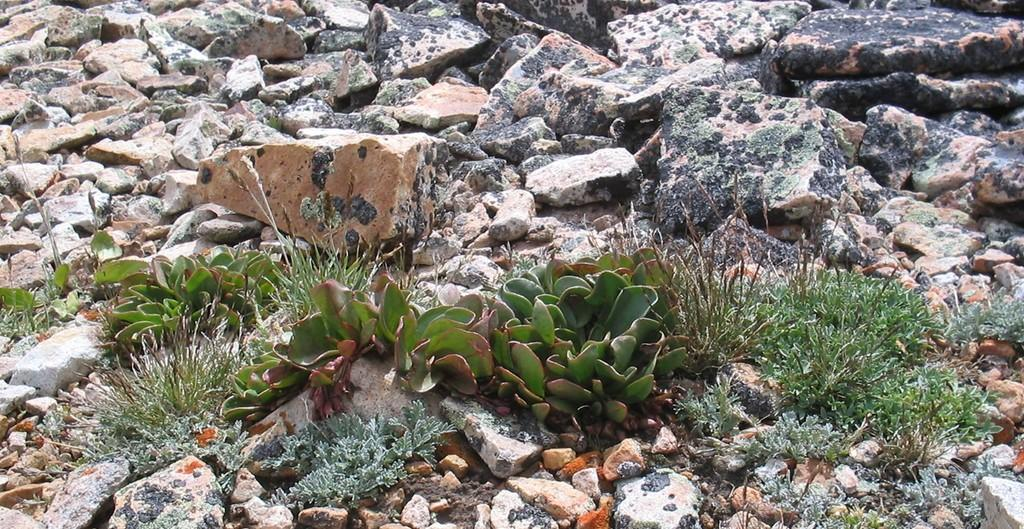What type of vegetation can be seen in the image? There are plants in the image. What other elements are present in the image besides plants? There are stones and grass in the image. How many loaves of bread can be seen in the image? There are no loaves of bread present in the image. What type of giant creatures are visible in the image? There are no giant creatures visible in the image. 